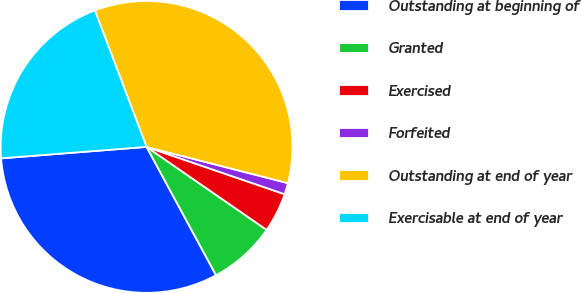Convert chart. <chart><loc_0><loc_0><loc_500><loc_500><pie_chart><fcel>Outstanding at beginning of<fcel>Granted<fcel>Exercised<fcel>Forfeited<fcel>Outstanding at end of year<fcel>Exercisable at end of year<nl><fcel>31.65%<fcel>7.48%<fcel>4.37%<fcel>1.26%<fcel>34.76%<fcel>20.49%<nl></chart> 